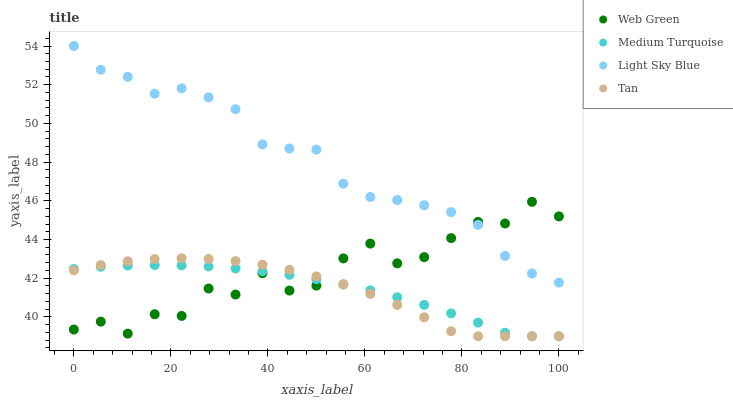Does Tan have the minimum area under the curve?
Answer yes or no. Yes. Does Light Sky Blue have the maximum area under the curve?
Answer yes or no. Yes. Does Medium Turquoise have the minimum area under the curve?
Answer yes or no. No. Does Medium Turquoise have the maximum area under the curve?
Answer yes or no. No. Is Medium Turquoise the smoothest?
Answer yes or no. Yes. Is Web Green the roughest?
Answer yes or no. Yes. Is Light Sky Blue the smoothest?
Answer yes or no. No. Is Light Sky Blue the roughest?
Answer yes or no. No. Does Tan have the lowest value?
Answer yes or no. Yes. Does Light Sky Blue have the lowest value?
Answer yes or no. No. Does Light Sky Blue have the highest value?
Answer yes or no. Yes. Does Medium Turquoise have the highest value?
Answer yes or no. No. Is Medium Turquoise less than Light Sky Blue?
Answer yes or no. Yes. Is Light Sky Blue greater than Tan?
Answer yes or no. Yes. Does Medium Turquoise intersect Tan?
Answer yes or no. Yes. Is Medium Turquoise less than Tan?
Answer yes or no. No. Is Medium Turquoise greater than Tan?
Answer yes or no. No. Does Medium Turquoise intersect Light Sky Blue?
Answer yes or no. No. 